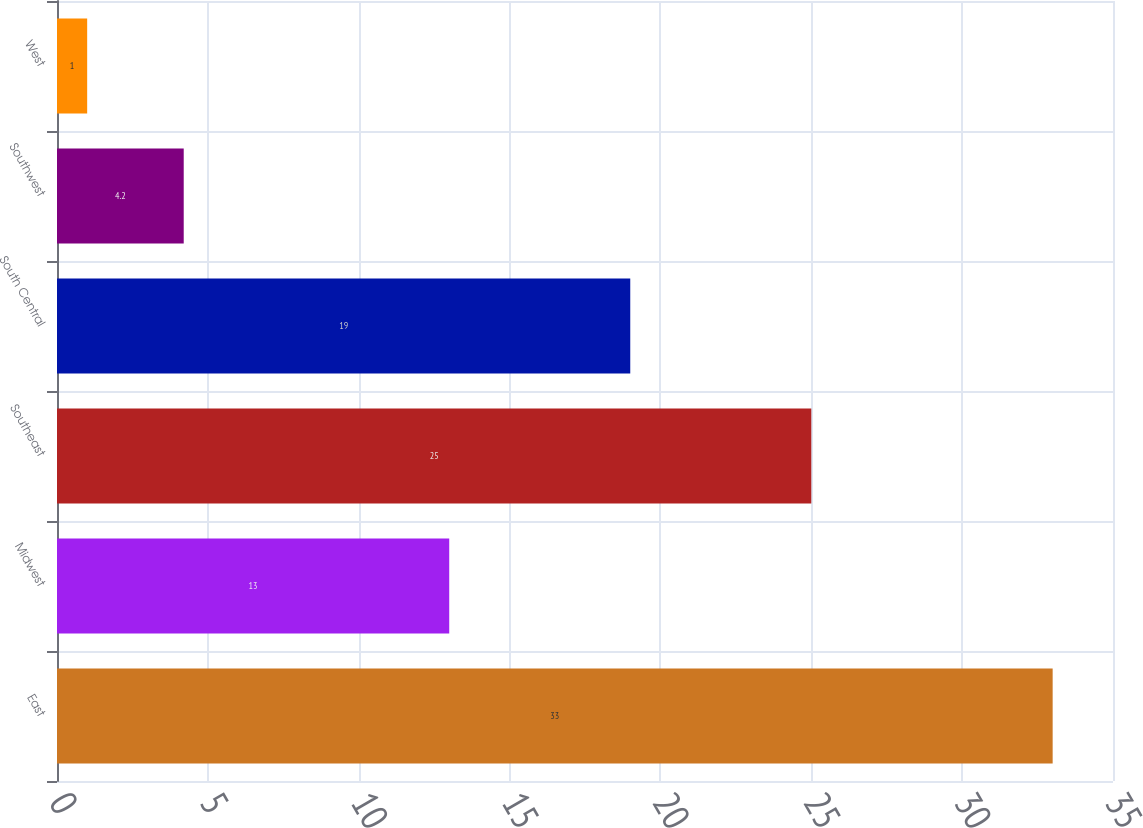Convert chart. <chart><loc_0><loc_0><loc_500><loc_500><bar_chart><fcel>East<fcel>Midwest<fcel>Southeast<fcel>South Central<fcel>Southwest<fcel>West<nl><fcel>33<fcel>13<fcel>25<fcel>19<fcel>4.2<fcel>1<nl></chart> 